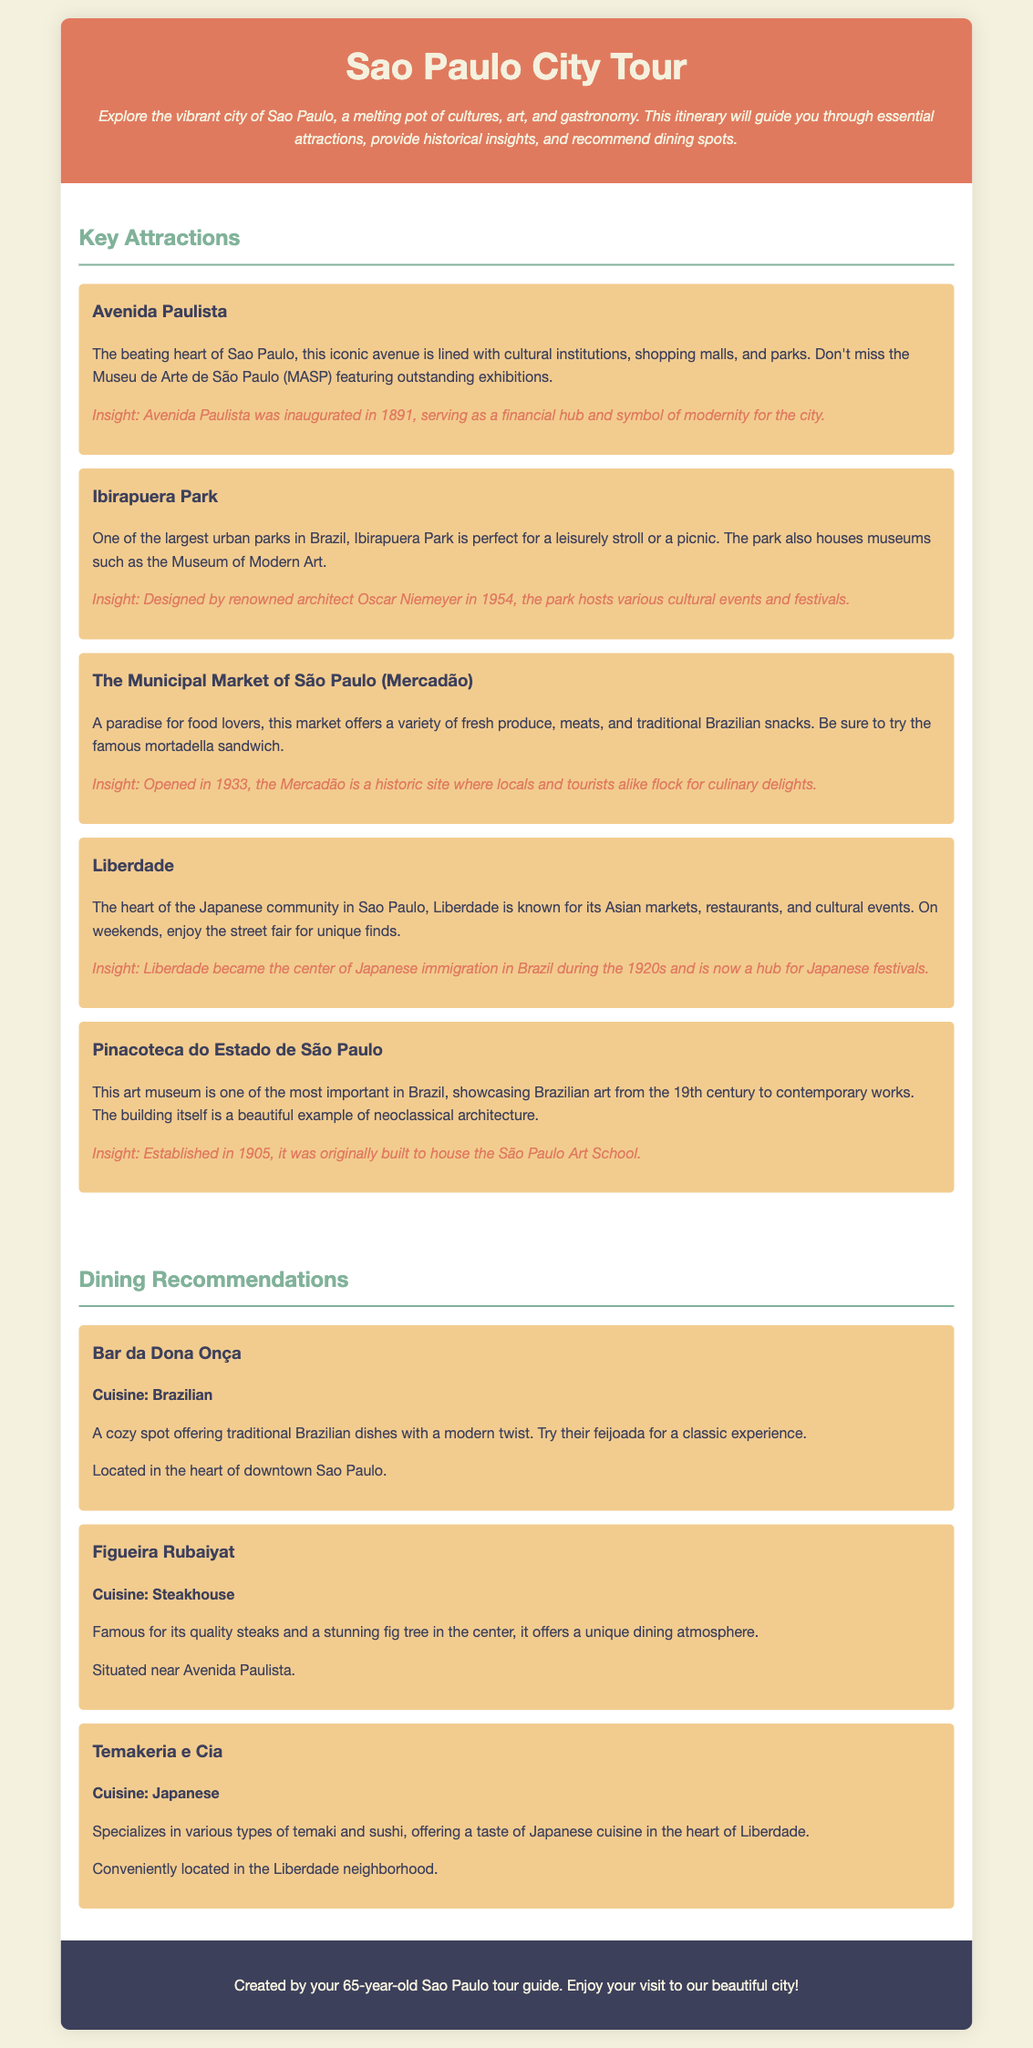What is the main cultural avenue in Sao Paulo? The document states that Avenida Paulista is the beating heart of Sao Paulo and a significant cultural avenue.
Answer: Avenida Paulista What year was Avenida Paulista inaugurated? The document mentions that Avenida Paulista was inaugurated in 1891.
Answer: 1891 Which park is known for hosting various cultural events and festivals? Ibirapuera Park is highlighted in the document as hosting cultural events and festivals.
Answer: Ibirapuera Park What is the famous sandwich to try at the Municipal Market of São Paulo? The document states that visitors should try the mortadella sandwich at the Mercadão.
Answer: Mortadella sandwich How many types of cuisine are mentioned in the dining recommendations section? The document lists three restaurants with different cuisines: Brazilian, Steakhouse, and Japanese.
Answer: Three What is the unique feature of Figueira Rubaiyat restaurant? The document indicates that Figueira Rubaiyat is famous for having a stunning fig tree in the center.
Answer: Fig tree What community is centered in Liberdade? The document specifies that Liberdade is the heart of the Japanese community in Sao Paulo.
Answer: Japanese community In what year did the Municipal Market of São Paulo open? The document mentions that the Mercadão opened in 1933.
Answer: 1933 